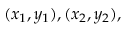Convert formula to latex. <formula><loc_0><loc_0><loc_500><loc_500>( x _ { 1 } , y _ { 1 } ) , ( x _ { 2 } , y _ { 2 } ) ,</formula> 